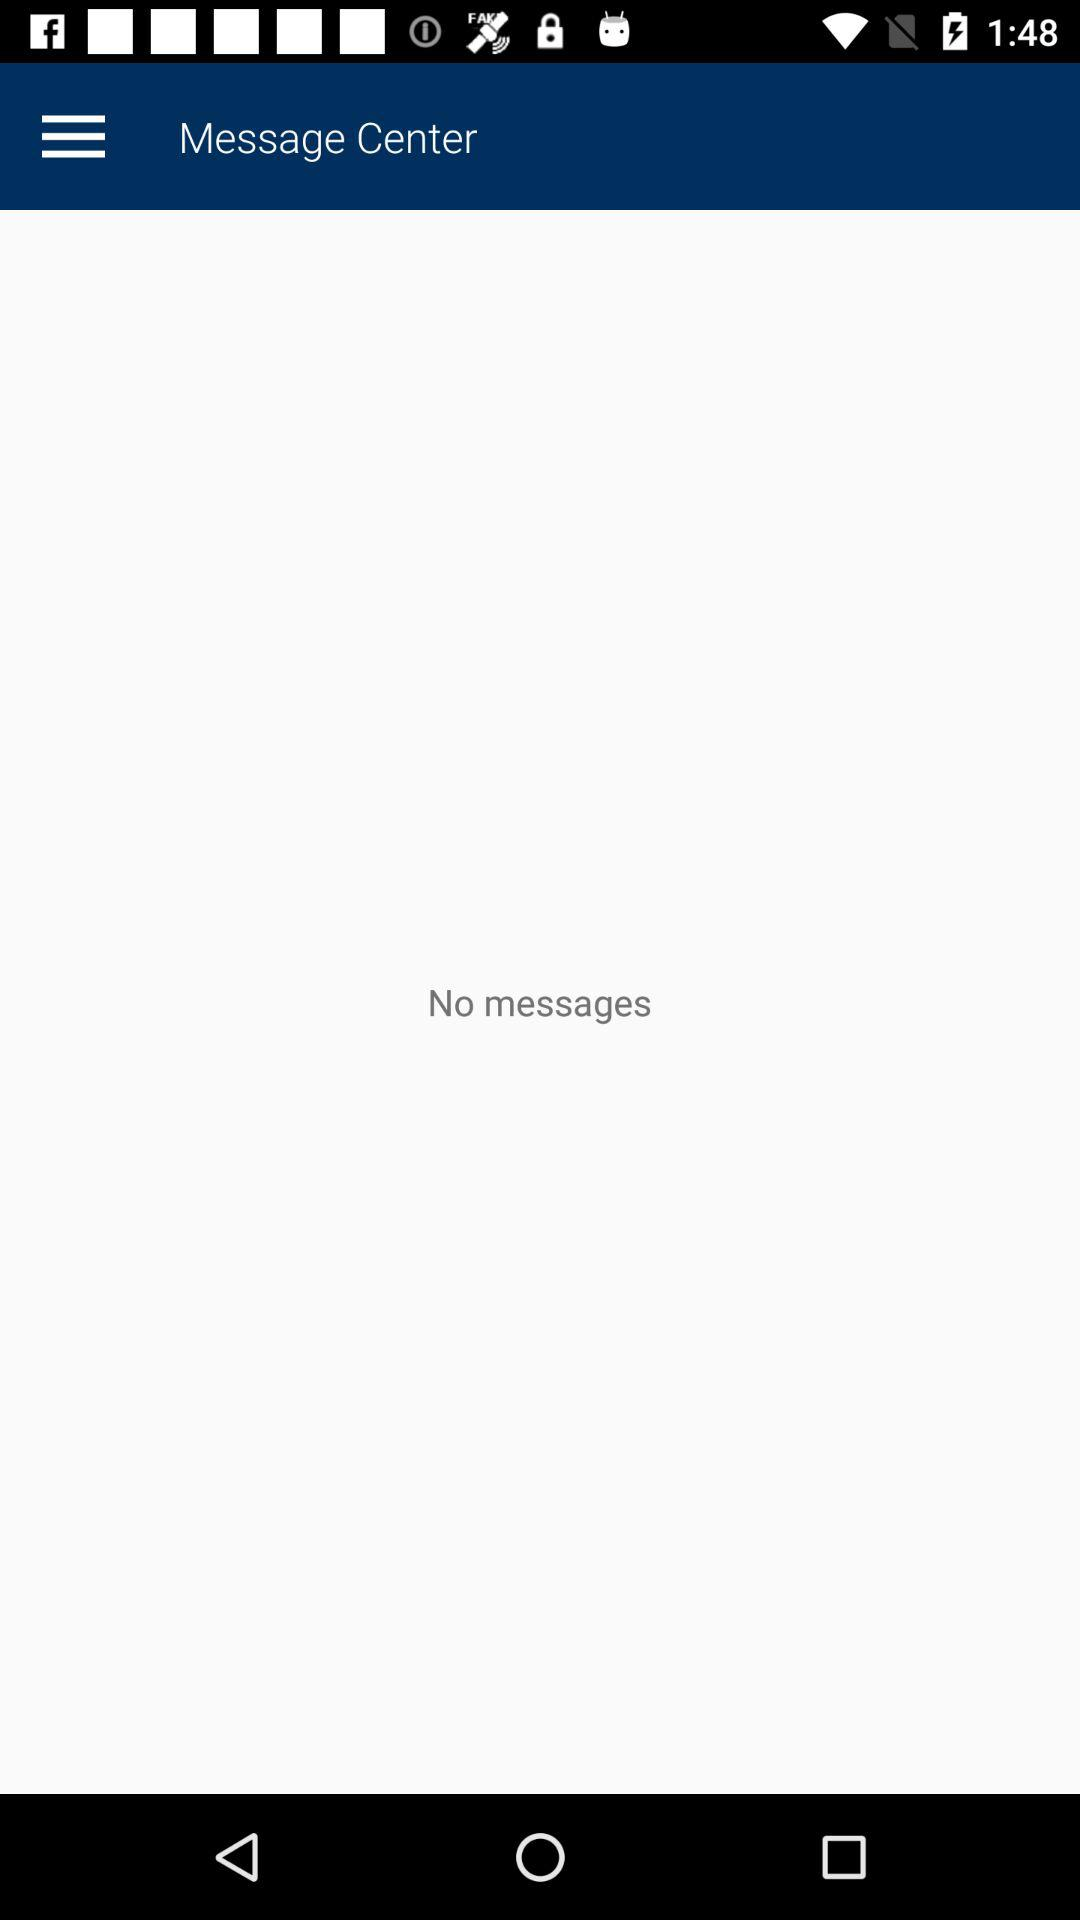How many messages are there? There are no messages. 